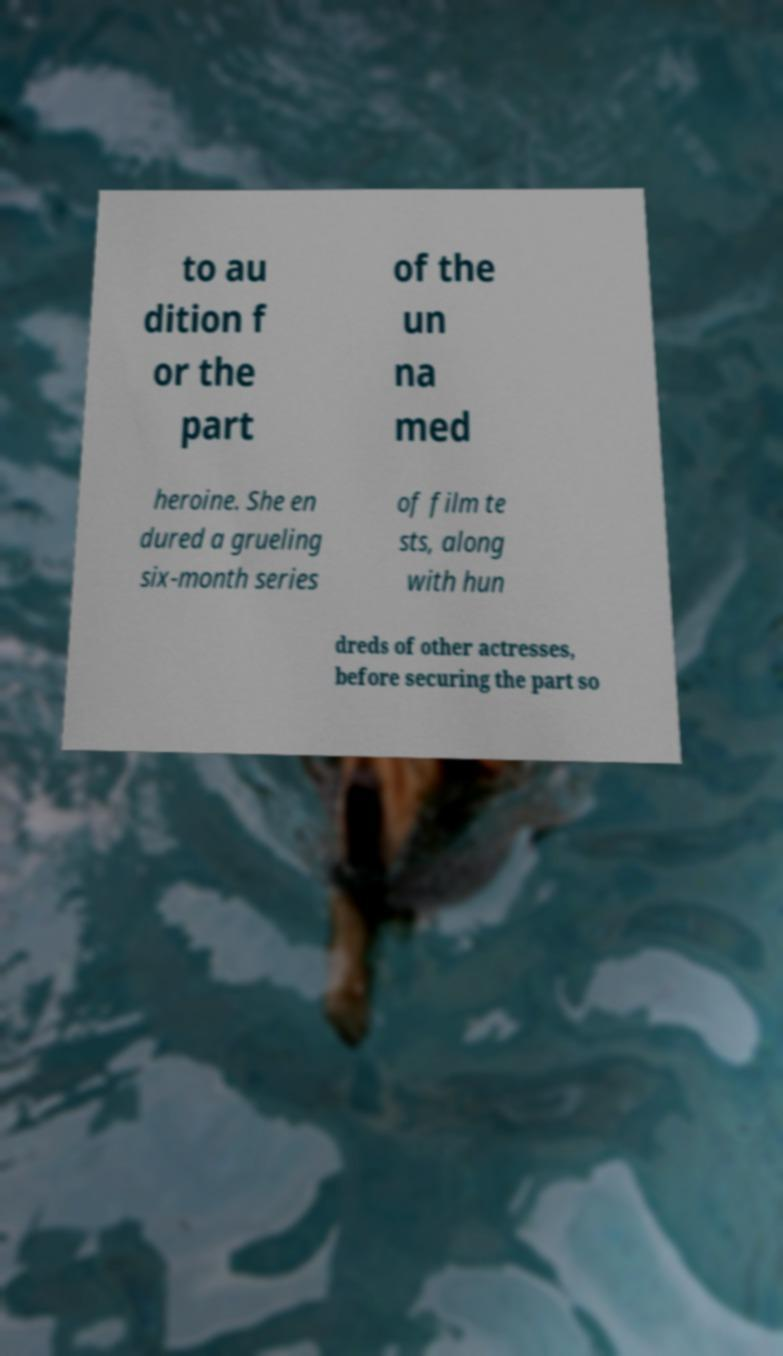I need the written content from this picture converted into text. Can you do that? to au dition f or the part of the un na med heroine. She en dured a grueling six-month series of film te sts, along with hun dreds of other actresses, before securing the part so 